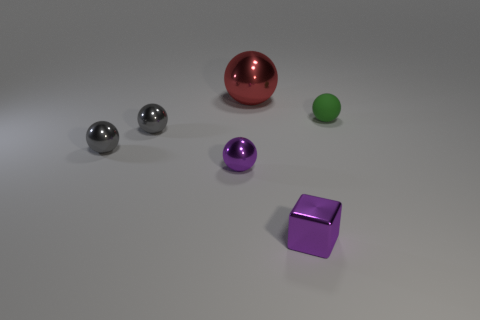How many red rubber things are the same shape as the tiny green rubber object?
Your response must be concise. 0. Is the green thing the same shape as the red object?
Your answer should be compact. Yes. What number of objects are either objects in front of the small green object or large cyan objects?
Ensure brevity in your answer.  4. There is a purple object that is to the left of the tiny purple shiny thing that is right of the sphere behind the tiny matte sphere; what is its shape?
Provide a short and direct response. Sphere. The tiny purple object that is the same material as the purple cube is what shape?
Keep it short and to the point. Sphere. What is the size of the red object?
Your response must be concise. Large. Do the green ball and the purple sphere have the same size?
Your answer should be compact. Yes. How many things are either metallic spheres that are behind the tiny purple ball or metallic balls that are in front of the green rubber ball?
Keep it short and to the point. 4. How many spheres are right of the shiny thing behind the matte thing in front of the red metal thing?
Give a very brief answer. 1. There is a metallic ball behind the rubber object; what size is it?
Provide a short and direct response. Large. 